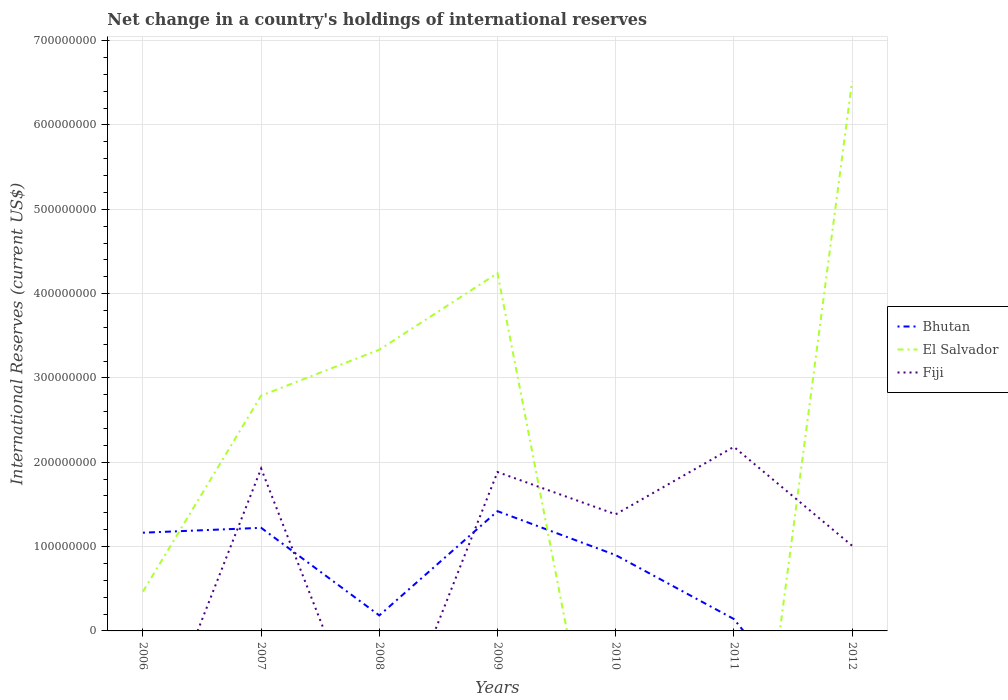What is the total international reserves in El Salvador in the graph?
Your answer should be compact. -9.07e+07. What is the difference between the highest and the second highest international reserves in El Salvador?
Provide a short and direct response. 6.52e+08. What is the difference between the highest and the lowest international reserves in El Salvador?
Offer a very short reply. 4. Is the international reserves in El Salvador strictly greater than the international reserves in Fiji over the years?
Ensure brevity in your answer.  No. How many lines are there?
Your response must be concise. 3. Does the graph contain any zero values?
Offer a very short reply. Yes. Does the graph contain grids?
Provide a short and direct response. Yes. Where does the legend appear in the graph?
Offer a terse response. Center right. How many legend labels are there?
Your response must be concise. 3. What is the title of the graph?
Provide a short and direct response. Net change in a country's holdings of international reserves. What is the label or title of the X-axis?
Provide a succinct answer. Years. What is the label or title of the Y-axis?
Offer a very short reply. International Reserves (current US$). What is the International Reserves (current US$) in Bhutan in 2006?
Give a very brief answer. 1.16e+08. What is the International Reserves (current US$) of El Salvador in 2006?
Offer a very short reply. 4.66e+07. What is the International Reserves (current US$) in Bhutan in 2007?
Your response must be concise. 1.22e+08. What is the International Reserves (current US$) in El Salvador in 2007?
Give a very brief answer. 2.79e+08. What is the International Reserves (current US$) of Fiji in 2007?
Provide a succinct answer. 1.93e+08. What is the International Reserves (current US$) of Bhutan in 2008?
Make the answer very short. 1.84e+07. What is the International Reserves (current US$) in El Salvador in 2008?
Ensure brevity in your answer.  3.33e+08. What is the International Reserves (current US$) in Fiji in 2008?
Your answer should be compact. 0. What is the International Reserves (current US$) in Bhutan in 2009?
Your answer should be compact. 1.42e+08. What is the International Reserves (current US$) in El Salvador in 2009?
Give a very brief answer. 4.24e+08. What is the International Reserves (current US$) of Fiji in 2009?
Provide a succinct answer. 1.88e+08. What is the International Reserves (current US$) of Bhutan in 2010?
Offer a very short reply. 8.99e+07. What is the International Reserves (current US$) of Fiji in 2010?
Keep it short and to the point. 1.38e+08. What is the International Reserves (current US$) in Bhutan in 2011?
Ensure brevity in your answer.  1.41e+07. What is the International Reserves (current US$) in Fiji in 2011?
Your response must be concise. 2.18e+08. What is the International Reserves (current US$) of El Salvador in 2012?
Your response must be concise. 6.52e+08. What is the International Reserves (current US$) in Fiji in 2012?
Ensure brevity in your answer.  1.01e+08. Across all years, what is the maximum International Reserves (current US$) of Bhutan?
Keep it short and to the point. 1.42e+08. Across all years, what is the maximum International Reserves (current US$) of El Salvador?
Ensure brevity in your answer.  6.52e+08. Across all years, what is the maximum International Reserves (current US$) in Fiji?
Provide a succinct answer. 2.18e+08. Across all years, what is the minimum International Reserves (current US$) in Bhutan?
Your answer should be very brief. 0. What is the total International Reserves (current US$) of Bhutan in the graph?
Offer a terse response. 5.03e+08. What is the total International Reserves (current US$) of El Salvador in the graph?
Keep it short and to the point. 1.73e+09. What is the total International Reserves (current US$) in Fiji in the graph?
Ensure brevity in your answer.  8.39e+08. What is the difference between the International Reserves (current US$) in Bhutan in 2006 and that in 2007?
Offer a very short reply. -5.80e+06. What is the difference between the International Reserves (current US$) in El Salvador in 2006 and that in 2007?
Provide a succinct answer. -2.32e+08. What is the difference between the International Reserves (current US$) of Bhutan in 2006 and that in 2008?
Offer a very short reply. 9.81e+07. What is the difference between the International Reserves (current US$) of El Salvador in 2006 and that in 2008?
Keep it short and to the point. -2.87e+08. What is the difference between the International Reserves (current US$) in Bhutan in 2006 and that in 2009?
Offer a very short reply. -2.55e+07. What is the difference between the International Reserves (current US$) of El Salvador in 2006 and that in 2009?
Keep it short and to the point. -3.78e+08. What is the difference between the International Reserves (current US$) in Bhutan in 2006 and that in 2010?
Provide a short and direct response. 2.66e+07. What is the difference between the International Reserves (current US$) of Bhutan in 2006 and that in 2011?
Offer a terse response. 1.02e+08. What is the difference between the International Reserves (current US$) of El Salvador in 2006 and that in 2012?
Give a very brief answer. -6.05e+08. What is the difference between the International Reserves (current US$) of Bhutan in 2007 and that in 2008?
Provide a short and direct response. 1.04e+08. What is the difference between the International Reserves (current US$) in El Salvador in 2007 and that in 2008?
Make the answer very short. -5.45e+07. What is the difference between the International Reserves (current US$) of Bhutan in 2007 and that in 2009?
Offer a terse response. -1.97e+07. What is the difference between the International Reserves (current US$) in El Salvador in 2007 and that in 2009?
Make the answer very short. -1.45e+08. What is the difference between the International Reserves (current US$) of Fiji in 2007 and that in 2009?
Provide a short and direct response. 4.16e+06. What is the difference between the International Reserves (current US$) in Bhutan in 2007 and that in 2010?
Offer a very short reply. 3.24e+07. What is the difference between the International Reserves (current US$) of Fiji in 2007 and that in 2010?
Offer a very short reply. 5.43e+07. What is the difference between the International Reserves (current US$) of Bhutan in 2007 and that in 2011?
Give a very brief answer. 1.08e+08. What is the difference between the International Reserves (current US$) of Fiji in 2007 and that in 2011?
Offer a terse response. -2.57e+07. What is the difference between the International Reserves (current US$) in El Salvador in 2007 and that in 2012?
Provide a short and direct response. -3.73e+08. What is the difference between the International Reserves (current US$) of Fiji in 2007 and that in 2012?
Offer a very short reply. 9.15e+07. What is the difference between the International Reserves (current US$) in Bhutan in 2008 and that in 2009?
Your answer should be compact. -1.24e+08. What is the difference between the International Reserves (current US$) in El Salvador in 2008 and that in 2009?
Your response must be concise. -9.07e+07. What is the difference between the International Reserves (current US$) in Bhutan in 2008 and that in 2010?
Offer a very short reply. -7.15e+07. What is the difference between the International Reserves (current US$) of Bhutan in 2008 and that in 2011?
Make the answer very short. 4.26e+06. What is the difference between the International Reserves (current US$) in El Salvador in 2008 and that in 2012?
Offer a very short reply. -3.18e+08. What is the difference between the International Reserves (current US$) in Bhutan in 2009 and that in 2010?
Your answer should be compact. 5.21e+07. What is the difference between the International Reserves (current US$) in Fiji in 2009 and that in 2010?
Your response must be concise. 5.01e+07. What is the difference between the International Reserves (current US$) in Bhutan in 2009 and that in 2011?
Your answer should be compact. 1.28e+08. What is the difference between the International Reserves (current US$) in Fiji in 2009 and that in 2011?
Provide a short and direct response. -2.98e+07. What is the difference between the International Reserves (current US$) in El Salvador in 2009 and that in 2012?
Keep it short and to the point. -2.27e+08. What is the difference between the International Reserves (current US$) of Fiji in 2009 and that in 2012?
Ensure brevity in your answer.  8.73e+07. What is the difference between the International Reserves (current US$) in Bhutan in 2010 and that in 2011?
Ensure brevity in your answer.  7.58e+07. What is the difference between the International Reserves (current US$) in Fiji in 2010 and that in 2011?
Your response must be concise. -8.00e+07. What is the difference between the International Reserves (current US$) of Fiji in 2010 and that in 2012?
Ensure brevity in your answer.  3.72e+07. What is the difference between the International Reserves (current US$) in Fiji in 2011 and that in 2012?
Make the answer very short. 1.17e+08. What is the difference between the International Reserves (current US$) of Bhutan in 2006 and the International Reserves (current US$) of El Salvador in 2007?
Your answer should be very brief. -1.63e+08. What is the difference between the International Reserves (current US$) in Bhutan in 2006 and the International Reserves (current US$) in Fiji in 2007?
Keep it short and to the point. -7.61e+07. What is the difference between the International Reserves (current US$) of El Salvador in 2006 and the International Reserves (current US$) of Fiji in 2007?
Provide a short and direct response. -1.46e+08. What is the difference between the International Reserves (current US$) of Bhutan in 2006 and the International Reserves (current US$) of El Salvador in 2008?
Your answer should be very brief. -2.17e+08. What is the difference between the International Reserves (current US$) of Bhutan in 2006 and the International Reserves (current US$) of El Salvador in 2009?
Offer a very short reply. -3.08e+08. What is the difference between the International Reserves (current US$) in Bhutan in 2006 and the International Reserves (current US$) in Fiji in 2009?
Offer a very short reply. -7.19e+07. What is the difference between the International Reserves (current US$) in El Salvador in 2006 and the International Reserves (current US$) in Fiji in 2009?
Ensure brevity in your answer.  -1.42e+08. What is the difference between the International Reserves (current US$) in Bhutan in 2006 and the International Reserves (current US$) in Fiji in 2010?
Make the answer very short. -2.18e+07. What is the difference between the International Reserves (current US$) of El Salvador in 2006 and the International Reserves (current US$) of Fiji in 2010?
Offer a very short reply. -9.17e+07. What is the difference between the International Reserves (current US$) of Bhutan in 2006 and the International Reserves (current US$) of Fiji in 2011?
Your answer should be very brief. -1.02e+08. What is the difference between the International Reserves (current US$) of El Salvador in 2006 and the International Reserves (current US$) of Fiji in 2011?
Offer a very short reply. -1.72e+08. What is the difference between the International Reserves (current US$) of Bhutan in 2006 and the International Reserves (current US$) of El Salvador in 2012?
Provide a short and direct response. -5.35e+08. What is the difference between the International Reserves (current US$) in Bhutan in 2006 and the International Reserves (current US$) in Fiji in 2012?
Your answer should be very brief. 1.54e+07. What is the difference between the International Reserves (current US$) of El Salvador in 2006 and the International Reserves (current US$) of Fiji in 2012?
Keep it short and to the point. -5.45e+07. What is the difference between the International Reserves (current US$) in Bhutan in 2007 and the International Reserves (current US$) in El Salvador in 2008?
Offer a very short reply. -2.11e+08. What is the difference between the International Reserves (current US$) in Bhutan in 2007 and the International Reserves (current US$) in El Salvador in 2009?
Your response must be concise. -3.02e+08. What is the difference between the International Reserves (current US$) of Bhutan in 2007 and the International Reserves (current US$) of Fiji in 2009?
Offer a very short reply. -6.61e+07. What is the difference between the International Reserves (current US$) in El Salvador in 2007 and the International Reserves (current US$) in Fiji in 2009?
Provide a succinct answer. 9.06e+07. What is the difference between the International Reserves (current US$) in Bhutan in 2007 and the International Reserves (current US$) in Fiji in 2010?
Make the answer very short. -1.60e+07. What is the difference between the International Reserves (current US$) in El Salvador in 2007 and the International Reserves (current US$) in Fiji in 2010?
Offer a terse response. 1.41e+08. What is the difference between the International Reserves (current US$) of Bhutan in 2007 and the International Reserves (current US$) of Fiji in 2011?
Provide a short and direct response. -9.60e+07. What is the difference between the International Reserves (current US$) of El Salvador in 2007 and the International Reserves (current US$) of Fiji in 2011?
Provide a succinct answer. 6.07e+07. What is the difference between the International Reserves (current US$) in Bhutan in 2007 and the International Reserves (current US$) in El Salvador in 2012?
Keep it short and to the point. -5.29e+08. What is the difference between the International Reserves (current US$) of Bhutan in 2007 and the International Reserves (current US$) of Fiji in 2012?
Offer a terse response. 2.12e+07. What is the difference between the International Reserves (current US$) in El Salvador in 2007 and the International Reserves (current US$) in Fiji in 2012?
Your answer should be compact. 1.78e+08. What is the difference between the International Reserves (current US$) of Bhutan in 2008 and the International Reserves (current US$) of El Salvador in 2009?
Offer a very short reply. -4.06e+08. What is the difference between the International Reserves (current US$) of Bhutan in 2008 and the International Reserves (current US$) of Fiji in 2009?
Offer a terse response. -1.70e+08. What is the difference between the International Reserves (current US$) in El Salvador in 2008 and the International Reserves (current US$) in Fiji in 2009?
Your response must be concise. 1.45e+08. What is the difference between the International Reserves (current US$) of Bhutan in 2008 and the International Reserves (current US$) of Fiji in 2010?
Provide a short and direct response. -1.20e+08. What is the difference between the International Reserves (current US$) of El Salvador in 2008 and the International Reserves (current US$) of Fiji in 2010?
Your response must be concise. 1.95e+08. What is the difference between the International Reserves (current US$) in Bhutan in 2008 and the International Reserves (current US$) in Fiji in 2011?
Provide a short and direct response. -2.00e+08. What is the difference between the International Reserves (current US$) of El Salvador in 2008 and the International Reserves (current US$) of Fiji in 2011?
Provide a succinct answer. 1.15e+08. What is the difference between the International Reserves (current US$) in Bhutan in 2008 and the International Reserves (current US$) in El Salvador in 2012?
Provide a succinct answer. -6.33e+08. What is the difference between the International Reserves (current US$) of Bhutan in 2008 and the International Reserves (current US$) of Fiji in 2012?
Offer a terse response. -8.27e+07. What is the difference between the International Reserves (current US$) of El Salvador in 2008 and the International Reserves (current US$) of Fiji in 2012?
Your response must be concise. 2.32e+08. What is the difference between the International Reserves (current US$) of Bhutan in 2009 and the International Reserves (current US$) of Fiji in 2010?
Offer a terse response. 3.72e+06. What is the difference between the International Reserves (current US$) in El Salvador in 2009 and the International Reserves (current US$) in Fiji in 2010?
Offer a very short reply. 2.86e+08. What is the difference between the International Reserves (current US$) of Bhutan in 2009 and the International Reserves (current US$) of Fiji in 2011?
Provide a succinct answer. -7.62e+07. What is the difference between the International Reserves (current US$) of El Salvador in 2009 and the International Reserves (current US$) of Fiji in 2011?
Offer a very short reply. 2.06e+08. What is the difference between the International Reserves (current US$) in Bhutan in 2009 and the International Reserves (current US$) in El Salvador in 2012?
Provide a short and direct response. -5.10e+08. What is the difference between the International Reserves (current US$) in Bhutan in 2009 and the International Reserves (current US$) in Fiji in 2012?
Provide a succinct answer. 4.09e+07. What is the difference between the International Reserves (current US$) in El Salvador in 2009 and the International Reserves (current US$) in Fiji in 2012?
Make the answer very short. 3.23e+08. What is the difference between the International Reserves (current US$) in Bhutan in 2010 and the International Reserves (current US$) in Fiji in 2011?
Your answer should be compact. -1.28e+08. What is the difference between the International Reserves (current US$) in Bhutan in 2010 and the International Reserves (current US$) in El Salvador in 2012?
Your answer should be compact. -5.62e+08. What is the difference between the International Reserves (current US$) of Bhutan in 2010 and the International Reserves (current US$) of Fiji in 2012?
Provide a short and direct response. -1.12e+07. What is the difference between the International Reserves (current US$) in Bhutan in 2011 and the International Reserves (current US$) in El Salvador in 2012?
Your answer should be very brief. -6.37e+08. What is the difference between the International Reserves (current US$) of Bhutan in 2011 and the International Reserves (current US$) of Fiji in 2012?
Provide a succinct answer. -8.70e+07. What is the average International Reserves (current US$) in Bhutan per year?
Offer a terse response. 7.19e+07. What is the average International Reserves (current US$) in El Salvador per year?
Give a very brief answer. 2.48e+08. What is the average International Reserves (current US$) in Fiji per year?
Give a very brief answer. 1.20e+08. In the year 2006, what is the difference between the International Reserves (current US$) in Bhutan and International Reserves (current US$) in El Salvador?
Your answer should be compact. 6.99e+07. In the year 2007, what is the difference between the International Reserves (current US$) of Bhutan and International Reserves (current US$) of El Salvador?
Provide a short and direct response. -1.57e+08. In the year 2007, what is the difference between the International Reserves (current US$) of Bhutan and International Reserves (current US$) of Fiji?
Provide a short and direct response. -7.03e+07. In the year 2007, what is the difference between the International Reserves (current US$) of El Salvador and International Reserves (current US$) of Fiji?
Your answer should be compact. 8.64e+07. In the year 2008, what is the difference between the International Reserves (current US$) of Bhutan and International Reserves (current US$) of El Salvador?
Keep it short and to the point. -3.15e+08. In the year 2009, what is the difference between the International Reserves (current US$) in Bhutan and International Reserves (current US$) in El Salvador?
Give a very brief answer. -2.82e+08. In the year 2009, what is the difference between the International Reserves (current US$) in Bhutan and International Reserves (current US$) in Fiji?
Your answer should be very brief. -4.64e+07. In the year 2009, what is the difference between the International Reserves (current US$) in El Salvador and International Reserves (current US$) in Fiji?
Provide a succinct answer. 2.36e+08. In the year 2010, what is the difference between the International Reserves (current US$) in Bhutan and International Reserves (current US$) in Fiji?
Your answer should be compact. -4.84e+07. In the year 2011, what is the difference between the International Reserves (current US$) of Bhutan and International Reserves (current US$) of Fiji?
Offer a terse response. -2.04e+08. In the year 2012, what is the difference between the International Reserves (current US$) of El Salvador and International Reserves (current US$) of Fiji?
Your answer should be compact. 5.50e+08. What is the ratio of the International Reserves (current US$) in Bhutan in 2006 to that in 2007?
Keep it short and to the point. 0.95. What is the ratio of the International Reserves (current US$) of El Salvador in 2006 to that in 2007?
Your response must be concise. 0.17. What is the ratio of the International Reserves (current US$) of Bhutan in 2006 to that in 2008?
Provide a succinct answer. 6.34. What is the ratio of the International Reserves (current US$) in El Salvador in 2006 to that in 2008?
Your answer should be compact. 0.14. What is the ratio of the International Reserves (current US$) in Bhutan in 2006 to that in 2009?
Give a very brief answer. 0.82. What is the ratio of the International Reserves (current US$) of El Salvador in 2006 to that in 2009?
Your response must be concise. 0.11. What is the ratio of the International Reserves (current US$) in Bhutan in 2006 to that in 2010?
Your answer should be compact. 1.3. What is the ratio of the International Reserves (current US$) of Bhutan in 2006 to that in 2011?
Make the answer very short. 8.25. What is the ratio of the International Reserves (current US$) of El Salvador in 2006 to that in 2012?
Your answer should be very brief. 0.07. What is the ratio of the International Reserves (current US$) of Bhutan in 2007 to that in 2008?
Provide a short and direct response. 6.65. What is the ratio of the International Reserves (current US$) in El Salvador in 2007 to that in 2008?
Give a very brief answer. 0.84. What is the ratio of the International Reserves (current US$) of Bhutan in 2007 to that in 2009?
Offer a terse response. 0.86. What is the ratio of the International Reserves (current US$) of El Salvador in 2007 to that in 2009?
Provide a short and direct response. 0.66. What is the ratio of the International Reserves (current US$) of Fiji in 2007 to that in 2009?
Your answer should be very brief. 1.02. What is the ratio of the International Reserves (current US$) of Bhutan in 2007 to that in 2010?
Make the answer very short. 1.36. What is the ratio of the International Reserves (current US$) of Fiji in 2007 to that in 2010?
Give a very brief answer. 1.39. What is the ratio of the International Reserves (current US$) of Bhutan in 2007 to that in 2011?
Offer a very short reply. 8.66. What is the ratio of the International Reserves (current US$) in Fiji in 2007 to that in 2011?
Ensure brevity in your answer.  0.88. What is the ratio of the International Reserves (current US$) of El Salvador in 2007 to that in 2012?
Make the answer very short. 0.43. What is the ratio of the International Reserves (current US$) in Fiji in 2007 to that in 2012?
Offer a terse response. 1.9. What is the ratio of the International Reserves (current US$) in Bhutan in 2008 to that in 2009?
Offer a very short reply. 0.13. What is the ratio of the International Reserves (current US$) in El Salvador in 2008 to that in 2009?
Ensure brevity in your answer.  0.79. What is the ratio of the International Reserves (current US$) in Bhutan in 2008 to that in 2010?
Ensure brevity in your answer.  0.2. What is the ratio of the International Reserves (current US$) of Bhutan in 2008 to that in 2011?
Your answer should be compact. 1.3. What is the ratio of the International Reserves (current US$) of El Salvador in 2008 to that in 2012?
Provide a succinct answer. 0.51. What is the ratio of the International Reserves (current US$) of Bhutan in 2009 to that in 2010?
Ensure brevity in your answer.  1.58. What is the ratio of the International Reserves (current US$) in Fiji in 2009 to that in 2010?
Offer a very short reply. 1.36. What is the ratio of the International Reserves (current US$) of Bhutan in 2009 to that in 2011?
Offer a terse response. 10.06. What is the ratio of the International Reserves (current US$) of Fiji in 2009 to that in 2011?
Your answer should be very brief. 0.86. What is the ratio of the International Reserves (current US$) in El Salvador in 2009 to that in 2012?
Your answer should be very brief. 0.65. What is the ratio of the International Reserves (current US$) in Fiji in 2009 to that in 2012?
Offer a very short reply. 1.86. What is the ratio of the International Reserves (current US$) in Bhutan in 2010 to that in 2011?
Offer a terse response. 6.37. What is the ratio of the International Reserves (current US$) of Fiji in 2010 to that in 2011?
Make the answer very short. 0.63. What is the ratio of the International Reserves (current US$) in Fiji in 2010 to that in 2012?
Offer a very short reply. 1.37. What is the ratio of the International Reserves (current US$) in Fiji in 2011 to that in 2012?
Ensure brevity in your answer.  2.16. What is the difference between the highest and the second highest International Reserves (current US$) in Bhutan?
Your response must be concise. 1.97e+07. What is the difference between the highest and the second highest International Reserves (current US$) of El Salvador?
Provide a succinct answer. 2.27e+08. What is the difference between the highest and the second highest International Reserves (current US$) in Fiji?
Keep it short and to the point. 2.57e+07. What is the difference between the highest and the lowest International Reserves (current US$) in Bhutan?
Offer a terse response. 1.42e+08. What is the difference between the highest and the lowest International Reserves (current US$) in El Salvador?
Ensure brevity in your answer.  6.52e+08. What is the difference between the highest and the lowest International Reserves (current US$) in Fiji?
Your answer should be compact. 2.18e+08. 